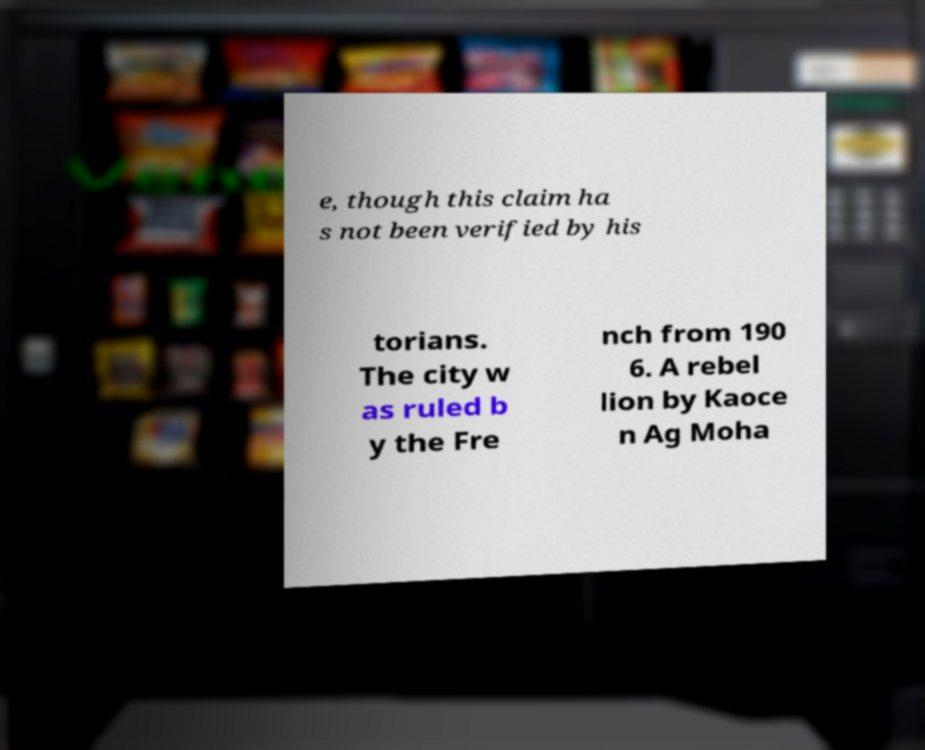I need the written content from this picture converted into text. Can you do that? e, though this claim ha s not been verified by his torians. The city w as ruled b y the Fre nch from 190 6. A rebel lion by Kaoce n Ag Moha 